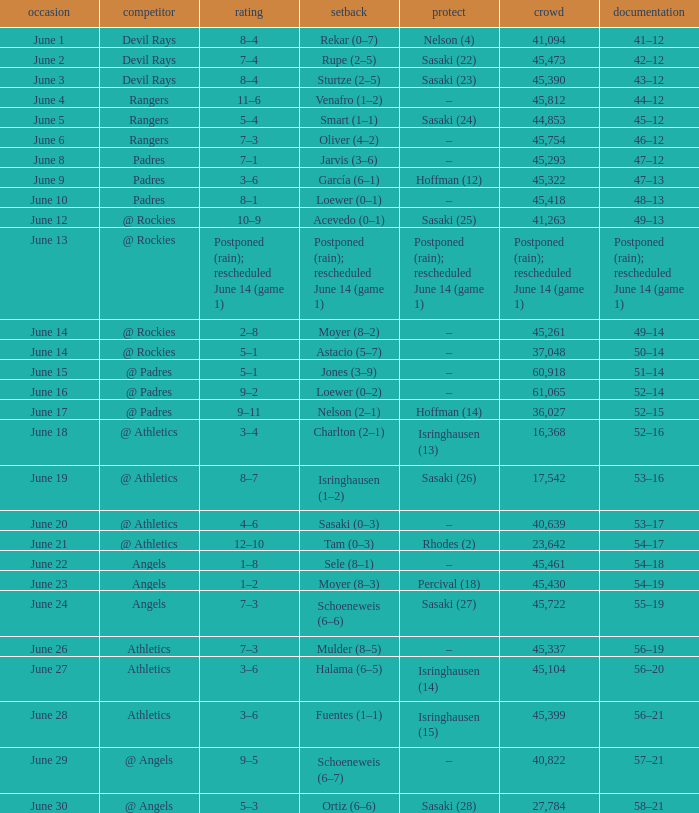What was the score of the Mariners game when they had a record of 56–21? 3–6. 